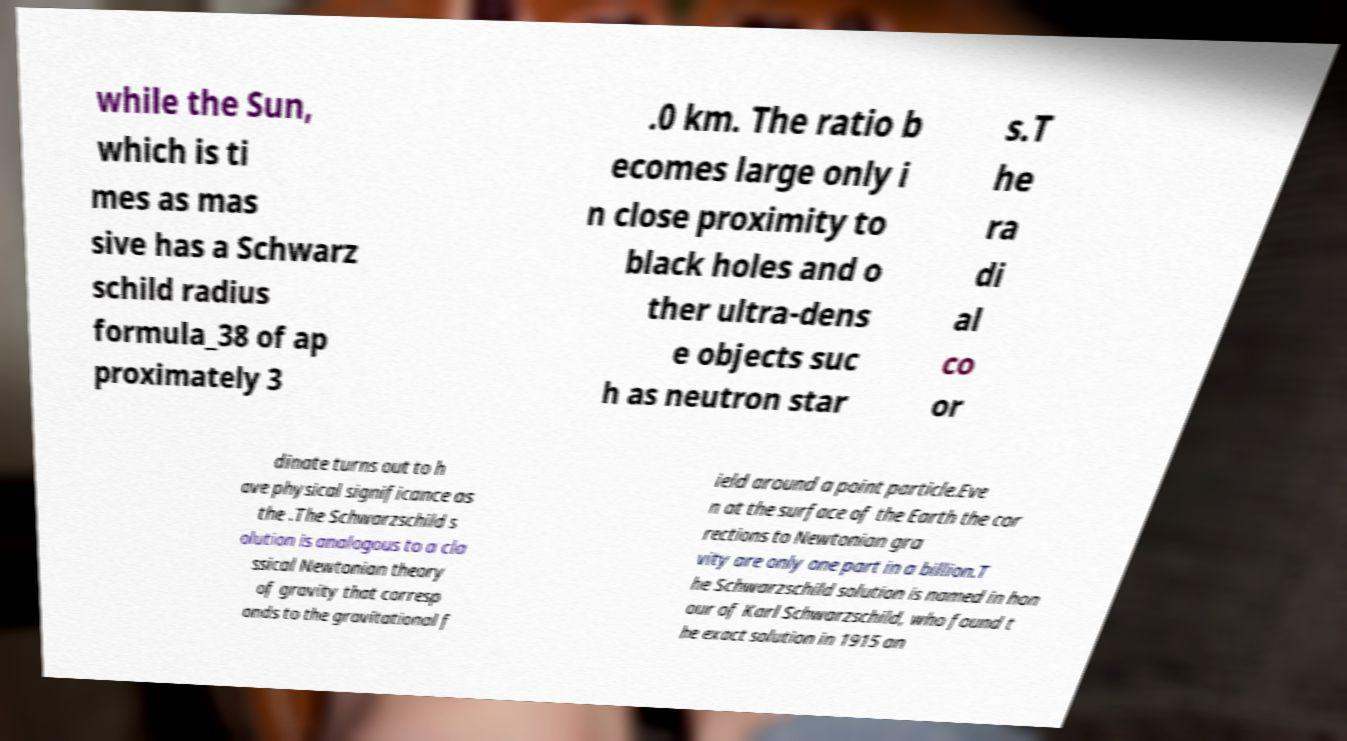Please identify and transcribe the text found in this image. while the Sun, which is ti mes as mas sive has a Schwarz schild radius formula_38 of ap proximately 3 .0 km. The ratio b ecomes large only i n close proximity to black holes and o ther ultra-dens e objects suc h as neutron star s.T he ra di al co or dinate turns out to h ave physical significance as the .The Schwarzschild s olution is analogous to a cla ssical Newtonian theory of gravity that corresp onds to the gravitational f ield around a point particle.Eve n at the surface of the Earth the cor rections to Newtonian gra vity are only one part in a billion.T he Schwarzschild solution is named in hon our of Karl Schwarzschild, who found t he exact solution in 1915 an 